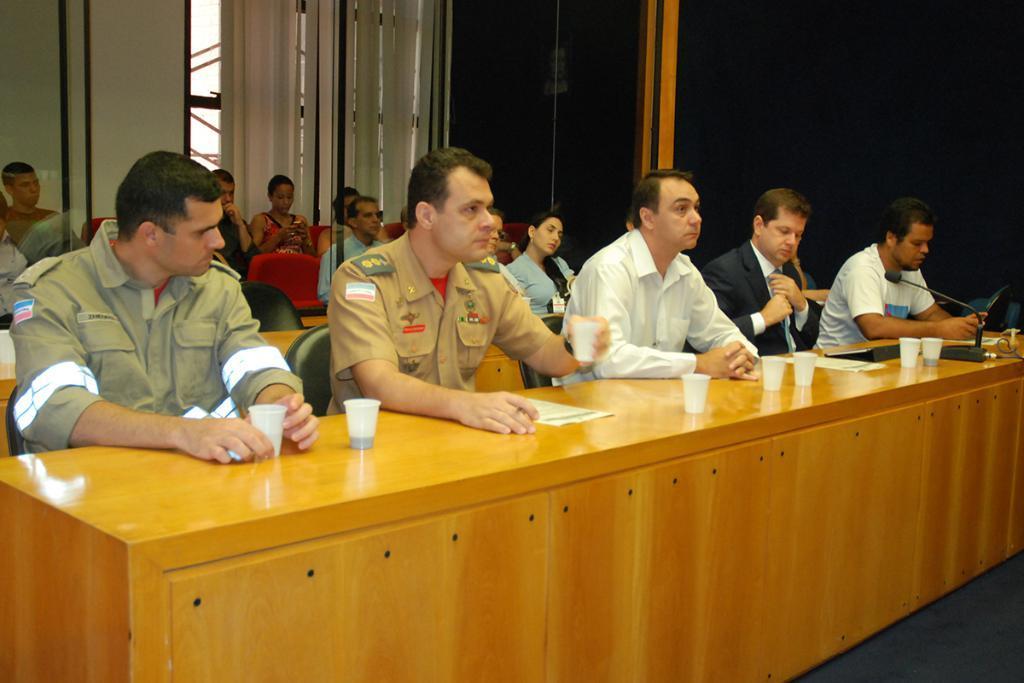Could you give a brief overview of what you see in this image? In this image I can see people sitting in a room. There are glasses, papers and a microphone in front of them. There are window blinds at the back. 